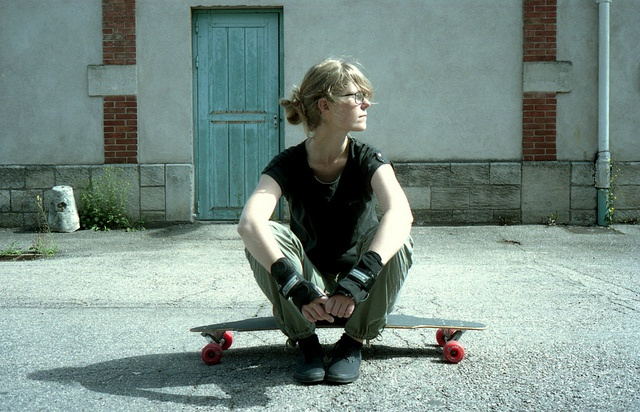Describe the objects in this image and their specific colors. I can see people in gray, black, ivory, and darkgray tones and skateboard in gray, black, darkgray, and maroon tones in this image. 